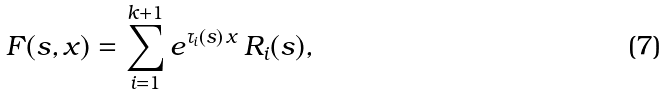Convert formula to latex. <formula><loc_0><loc_0><loc_500><loc_500>F ( s , x ) = \sum _ { i = 1 } ^ { k + 1 } e ^ { \tau _ { i } ( s ) \, x } \, R _ { i } ( s ) ,</formula> 